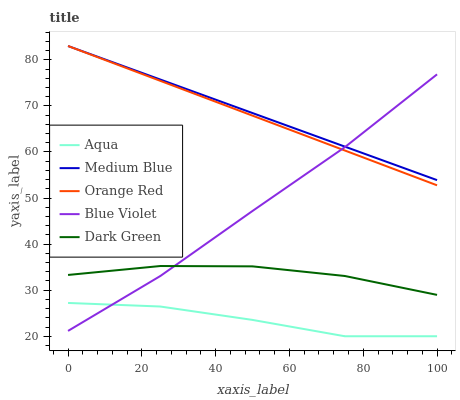Does Orange Red have the minimum area under the curve?
Answer yes or no. No. Does Orange Red have the maximum area under the curve?
Answer yes or no. No. Is Aqua the smoothest?
Answer yes or no. No. Is Orange Red the roughest?
Answer yes or no. No. Does Orange Red have the lowest value?
Answer yes or no. No. Does Aqua have the highest value?
Answer yes or no. No. Is Aqua less than Orange Red?
Answer yes or no. Yes. Is Orange Red greater than Dark Green?
Answer yes or no. Yes. Does Aqua intersect Orange Red?
Answer yes or no. No. 